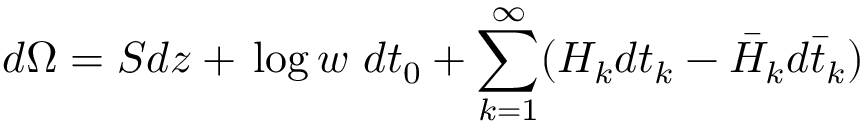Convert formula to latex. <formula><loc_0><loc_0><loc_500><loc_500>d \Omega = S d z + \, \log \, w \ d t _ { 0 } + \sum _ { k = 1 } ^ { \infty } ( H _ { k } d t _ { k } - \bar { H } _ { k } d \bar { t } _ { k } )</formula> 